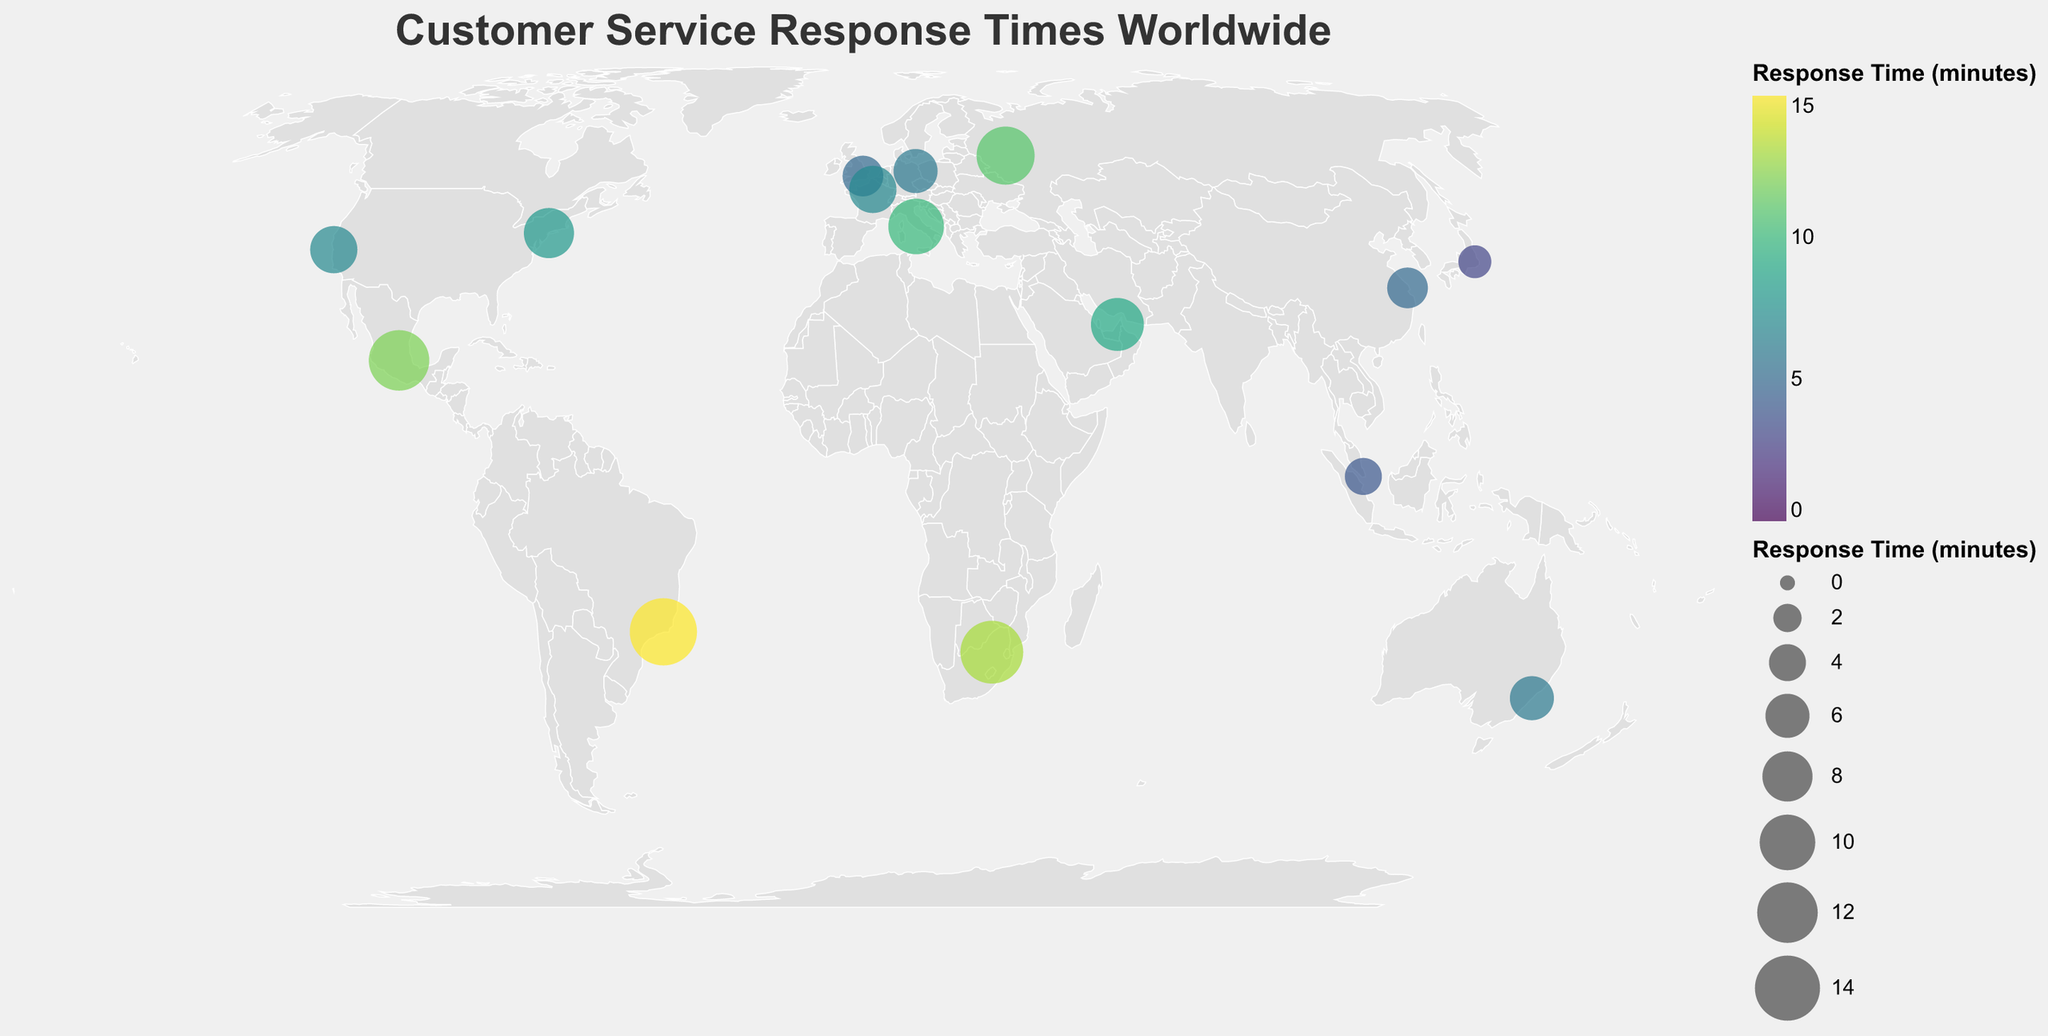What is the highest customer service response time shown on the map? The highest response time will be indicated by the largest circle size and the brightest color according to the scale. Find the circle with the highest value.
Answer: 15 minutes Which city has the fastest customer service response time depicted in the plot? Look through the legend and identify the smallest circle size and the least intense color, which corresponds to the shortest response time.
Answer: Tokyo What is the average customer service response time for all cities? Add all the response times and divide by the number of cities: (8 + 5 + 7 + 3 + 4 + 6 + 9 + 12 + 10 + 15 + 6 + 7 + 5 + 11 + 13) / 15.
Answer: 7.87 minutes How many cities have a customer service response time greater than 10 minutes? Identify all the cities where the response times exceed 10 minutes: Mexico City (12), Moscow (11), Johannesburg (13), Rio de Janeiro (15). Count these cities.
Answer: 4 cities Which country has a city with the second slowest customer service response time? Find the country corresponding to the second largest circle, after Rio de Janeiro, using the legend.
Answer: Johannesburg, South Africa How does the response time in New York City compare to that in London? Check both circles for New York City and London. The response time in New York City is 8 minutes and in London it is 5 minutes.
Answer: New York City is slower Identify all cities with a customer service response time of 5 minutes. Find and list all cities where the response time matches 5 minutes: London, Shanghai.
Answer: London, Shanghai What is the difference in response times between Rio de Janeiro and Paris? Subtract the response time of Paris (7 minutes) from that of Rio de Janeiro (15 minutes): 15 - 7.
Answer: 8 minutes Which city has a response time closest to the global average response time? Compute the average response time as 7.87 minutes and find the city closest to this value: Berlin and Sydney both have a response time of 6.
Answer: Berlin or Sydney How do the response times in USA cities (New York City and San Francisco) compare? Look at the two cities' response times. New York City is 8 minutes, and San Francisco is 7 minutes.
Answer: Almost the same, New York is slightly slower 